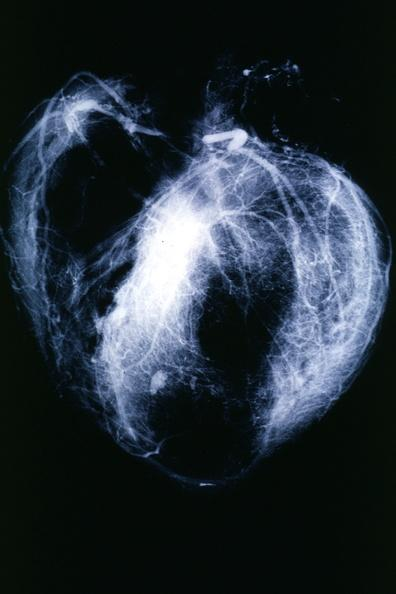s mesothelioma present?
Answer the question using a single word or phrase. No 